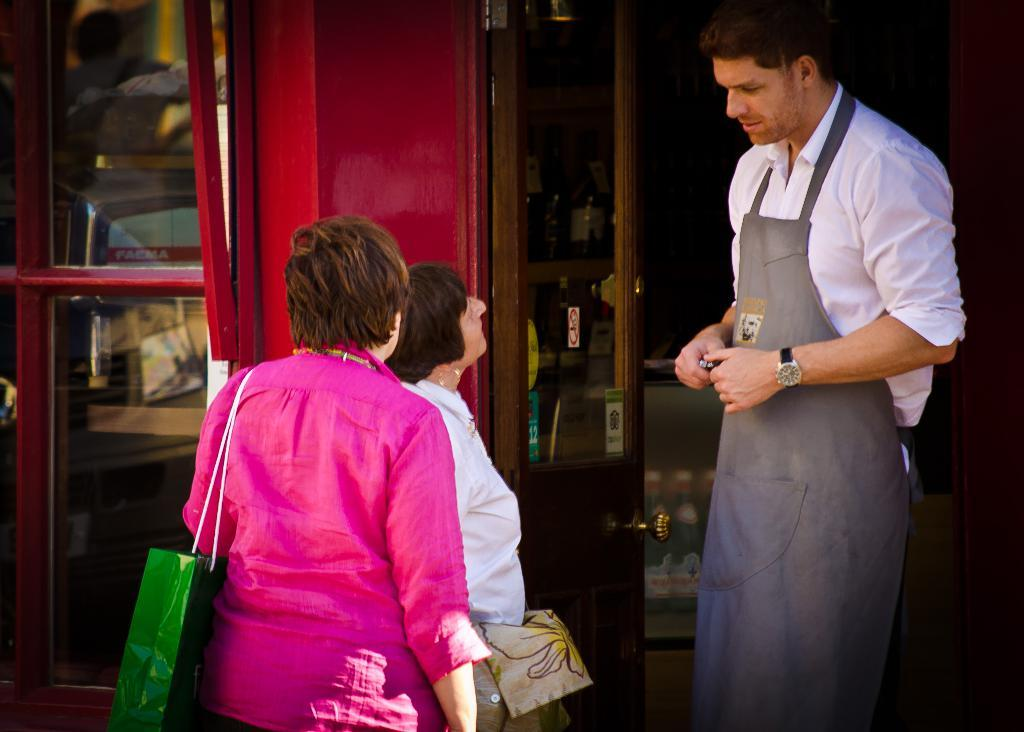What can be seen in the image? There are people standing in the image. What type of door is visible in the image? There is a glass door in the image. What architectural feature can be seen in the image? There is a wall visible in the image. How many children are playing with the appliance in the image? There are no children or appliances present in the image. 